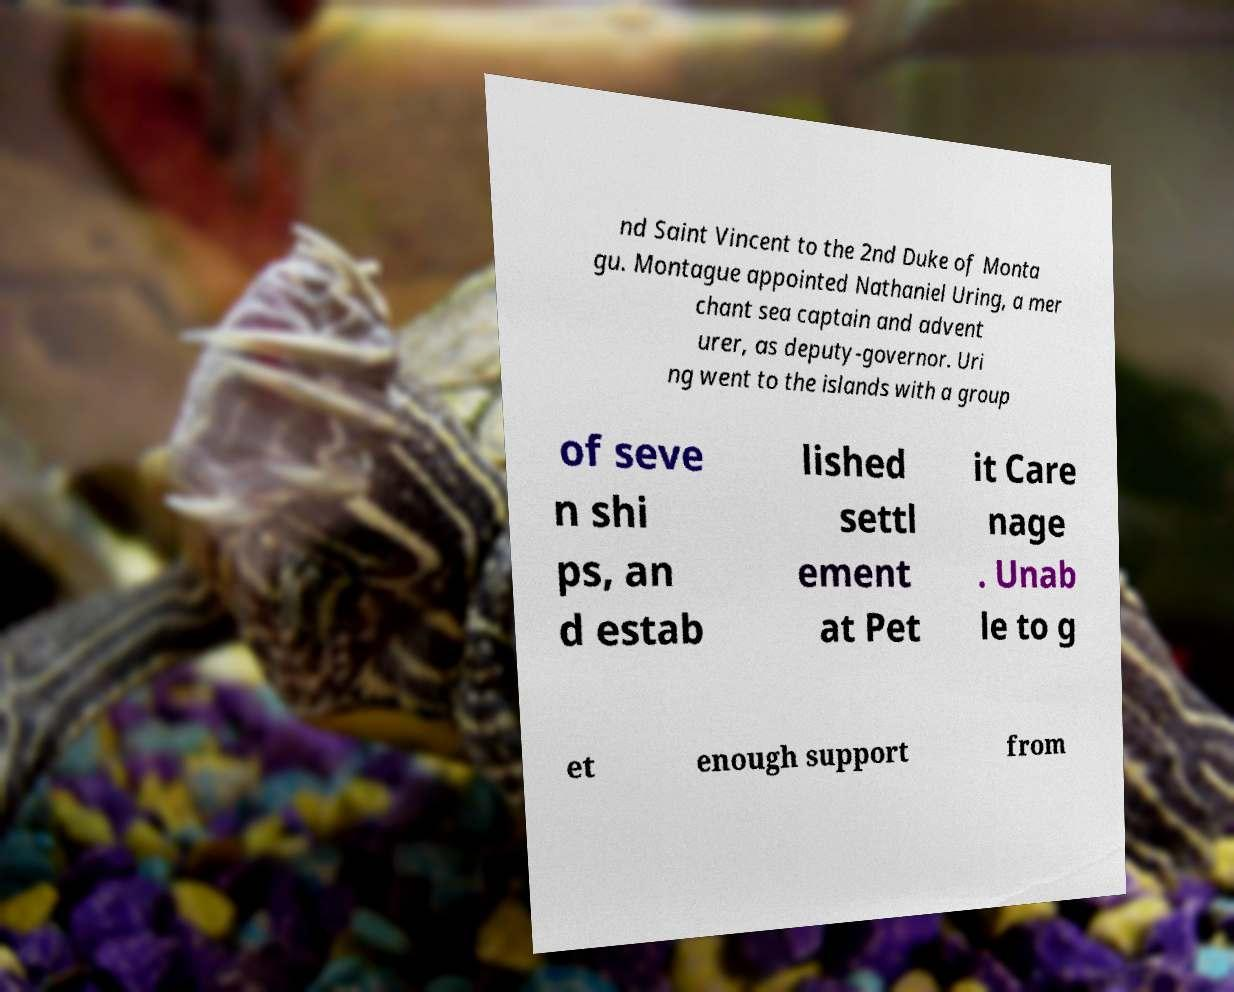Please read and relay the text visible in this image. What does it say? nd Saint Vincent to the 2nd Duke of Monta gu. Montague appointed Nathaniel Uring, a mer chant sea captain and advent urer, as deputy-governor. Uri ng went to the islands with a group of seve n shi ps, an d estab lished settl ement at Pet it Care nage . Unab le to g et enough support from 